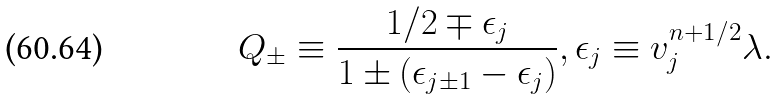<formula> <loc_0><loc_0><loc_500><loc_500>Q _ { \pm } \equiv \frac { 1 / 2 \mp \epsilon _ { j } } { 1 \pm ( \epsilon _ { j \pm 1 } - \epsilon _ { j } ) } , \epsilon _ { j } \equiv v _ { j } ^ { n + 1 / 2 } \lambda .</formula> 